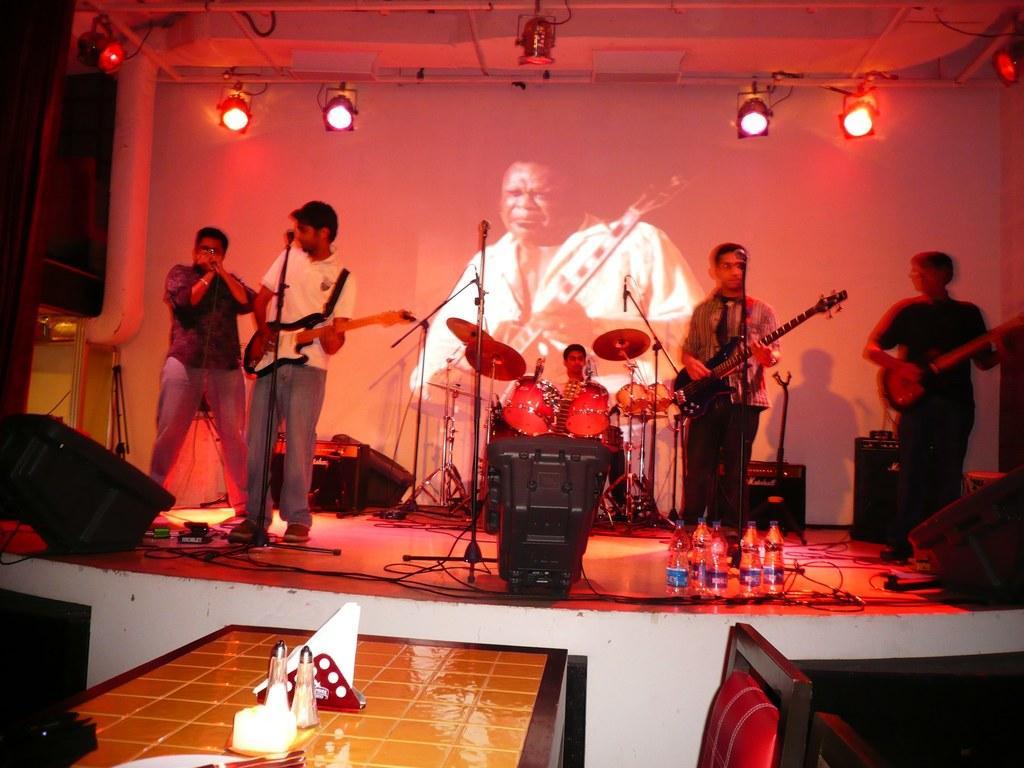Can you describe this image briefly? This is is the picture of five people standing on the stage and playing musical instruments and in front of them there are some speakers, lights and bottles. 